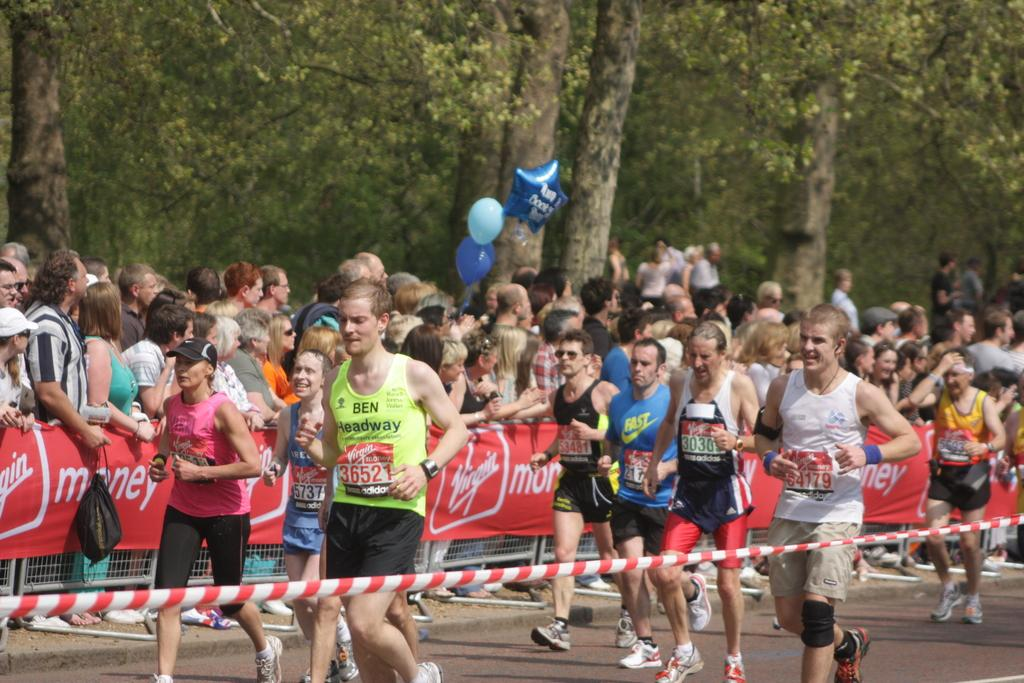What are the people in the image doing? The people in the image are walking on the road. What else can be seen in the image besides the people walking? Banners, a fence, balloons, a bag, and a group of people standing are visible in the image. What is in the background of the image? Trees are present in the background of the image. What type of twist can be seen in the image? There is no twist present in the image. What activity are the people participating in, as seen in the image? The image does not show a specific activity; it only shows people walking on the road and a group of people standing. 